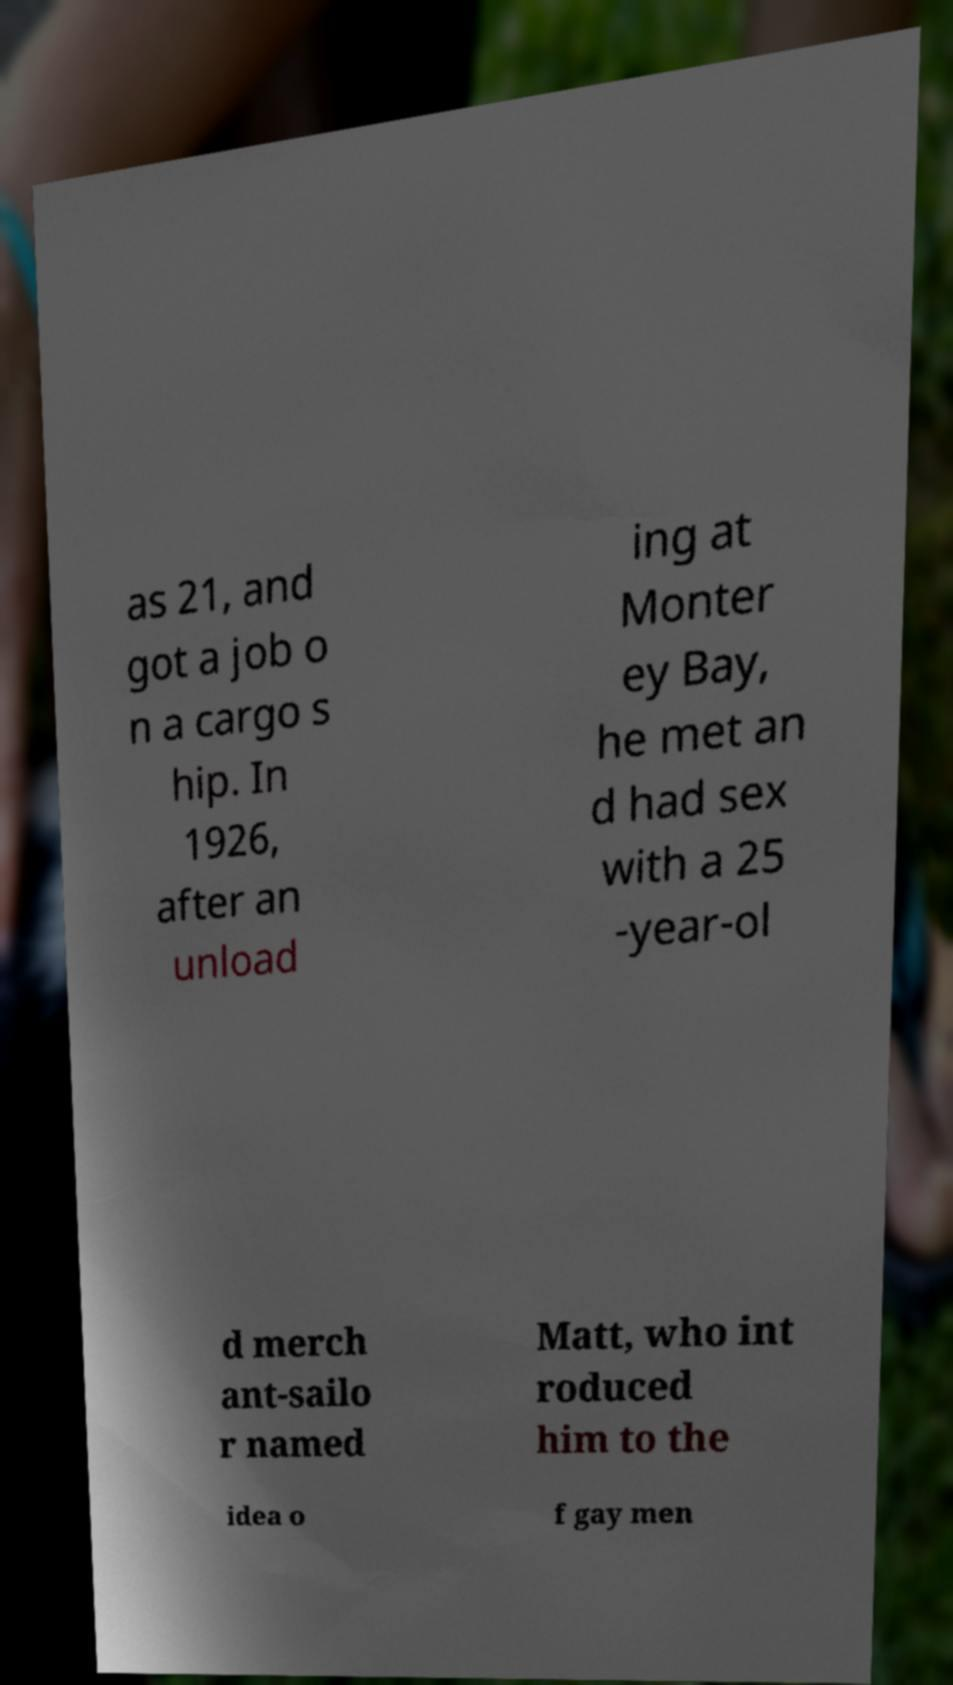Can you accurately transcribe the text from the provided image for me? as 21, and got a job o n a cargo s hip. In 1926, after an unload ing at Monter ey Bay, he met an d had sex with a 25 -year-ol d merch ant-sailo r named Matt, who int roduced him to the idea o f gay men 